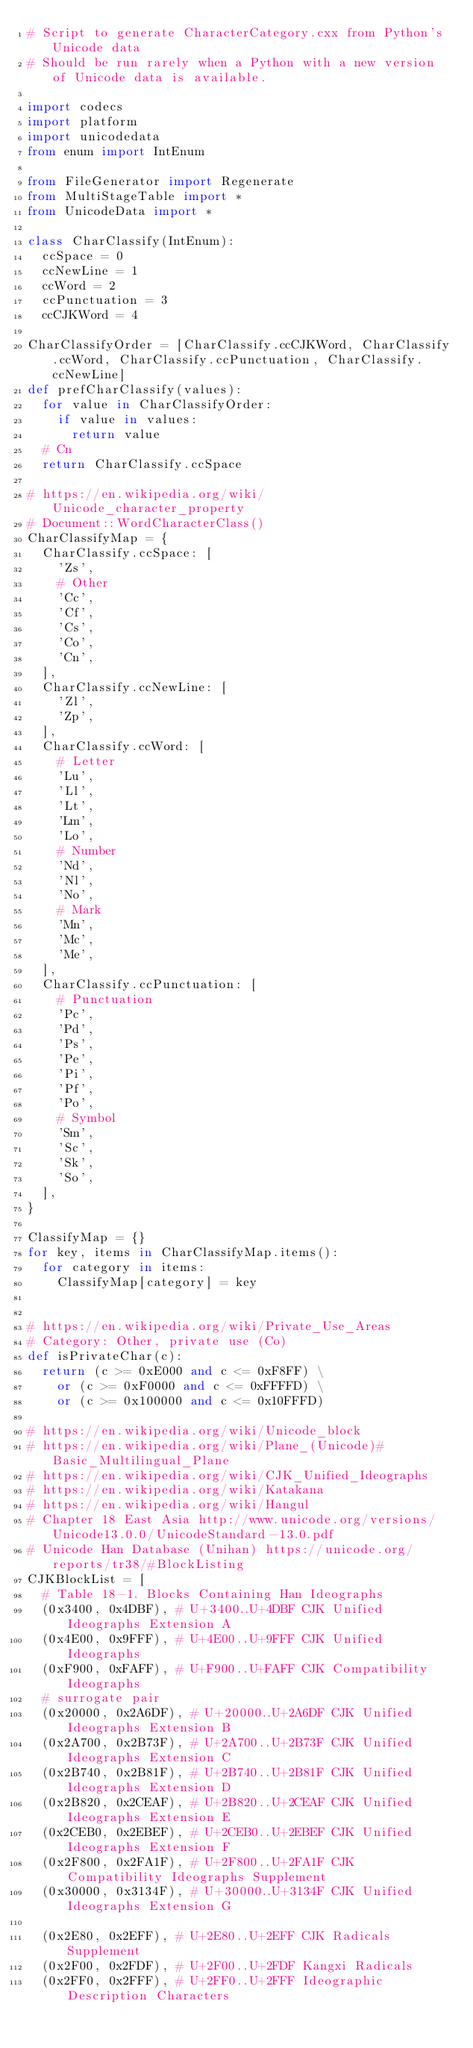<code> <loc_0><loc_0><loc_500><loc_500><_Python_># Script to generate CharacterCategory.cxx from Python's Unicode data
# Should be run rarely when a Python with a new version of Unicode data is available.

import codecs
import platform
import unicodedata
from enum import IntEnum

from FileGenerator import Regenerate
from MultiStageTable import *
from UnicodeData import *

class CharClassify(IntEnum):
	ccSpace = 0
	ccNewLine = 1
	ccWord = 2
	ccPunctuation = 3
	ccCJKWord = 4

CharClassifyOrder = [CharClassify.ccCJKWord, CharClassify.ccWord, CharClassify.ccPunctuation, CharClassify.ccNewLine]
def prefCharClassify(values):
	for value in CharClassifyOrder:
		if value in values:
			return value
	# Cn
	return CharClassify.ccSpace

# https://en.wikipedia.org/wiki/Unicode_character_property
# Document::WordCharacterClass()
CharClassifyMap = {
	CharClassify.ccSpace: [
		'Zs',
		# Other
		'Cc',
		'Cf',
		'Cs',
		'Co',
		'Cn',
	],
	CharClassify.ccNewLine: [
		'Zl',
		'Zp',
	],
	CharClassify.ccWord: [
		# Letter
		'Lu',
		'Ll',
		'Lt',
		'Lm',
		'Lo',
		# Number
		'Nd',
		'Nl',
		'No',
		# Mark
		'Mn',
		'Mc',
		'Me',
	],
	CharClassify.ccPunctuation: [
		# Punctuation
		'Pc',
		'Pd',
		'Ps',
		'Pe',
		'Pi',
		'Pf',
		'Po',
		# Symbol
		'Sm',
		'Sc',
		'Sk',
		'So',
	],
}

ClassifyMap = {}
for key, items in CharClassifyMap.items():
	for category in items:
		ClassifyMap[category] = key


# https://en.wikipedia.org/wiki/Private_Use_Areas
# Category: Other, private use (Co)
def isPrivateChar(c):
	return (c >= 0xE000 and c <= 0xF8FF) \
		or (c >= 0xF0000 and c <= 0xFFFFD) \
		or (c >= 0x100000 and c <= 0x10FFFD)

# https://en.wikipedia.org/wiki/Unicode_block
# https://en.wikipedia.org/wiki/Plane_(Unicode)#Basic_Multilingual_Plane
# https://en.wikipedia.org/wiki/CJK_Unified_Ideographs
# https://en.wikipedia.org/wiki/Katakana
# https://en.wikipedia.org/wiki/Hangul
# Chapter 18 East Asia http://www.unicode.org/versions/Unicode13.0.0/UnicodeStandard-13.0.pdf
# Unicode Han Database (Unihan) https://unicode.org/reports/tr38/#BlockListing
CJKBlockList = [
	# Table 18-1. Blocks Containing Han Ideographs
	(0x3400, 0x4DBF), # U+3400..U+4DBF CJK Unified Ideographs Extension A
	(0x4E00, 0x9FFF), # U+4E00..U+9FFF CJK Unified Ideographs
	(0xF900, 0xFAFF), # U+F900..U+FAFF CJK Compatibility Ideographs
	# surrogate pair
	(0x20000, 0x2A6DF), # U+20000..U+2A6DF CJK Unified Ideographs Extension B
	(0x2A700, 0x2B73F), # U+2A700..U+2B73F CJK Unified Ideographs Extension C
	(0x2B740, 0x2B81F), # U+2B740..U+2B81F CJK Unified Ideographs Extension D
	(0x2B820, 0x2CEAF), # U+2B820..U+2CEAF CJK Unified Ideographs Extension E
	(0x2CEB0, 0x2EBEF), # U+2CEB0..U+2EBEF CJK Unified Ideographs Extension F
	(0x2F800, 0x2FA1F), # U+2F800..U+2FA1F CJK Compatibility Ideographs Supplement
	(0x30000, 0x3134F), # U+30000..U+3134F CJK Unified Ideographs Extension G

	(0x2E80, 0x2EFF), # U+2E80..U+2EFF CJK Radicals Supplement
	(0x2F00, 0x2FDF), # U+2F00..U+2FDF Kangxi Radicals
	(0x2FF0, 0x2FFF), # U+2FF0..U+2FFF Ideographic Description Characters</code> 